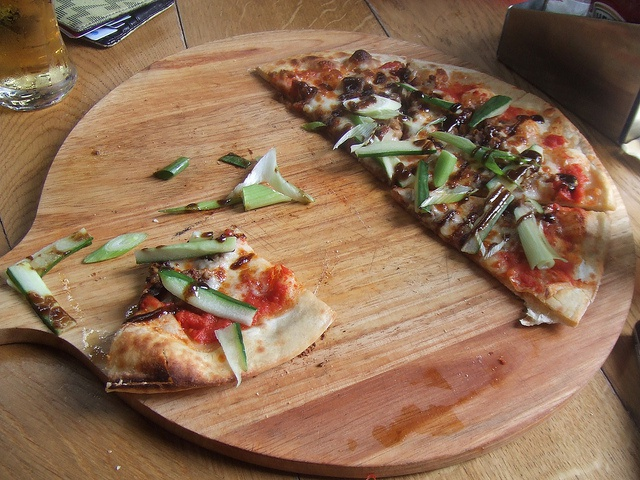Describe the objects in this image and their specific colors. I can see dining table in maroon, gray, brown, and tan tones, pizza in maroon, black, and gray tones, pizza in maroon and tan tones, cup in maroon, olive, and gray tones, and bottle in maroon, olive, and gray tones in this image. 